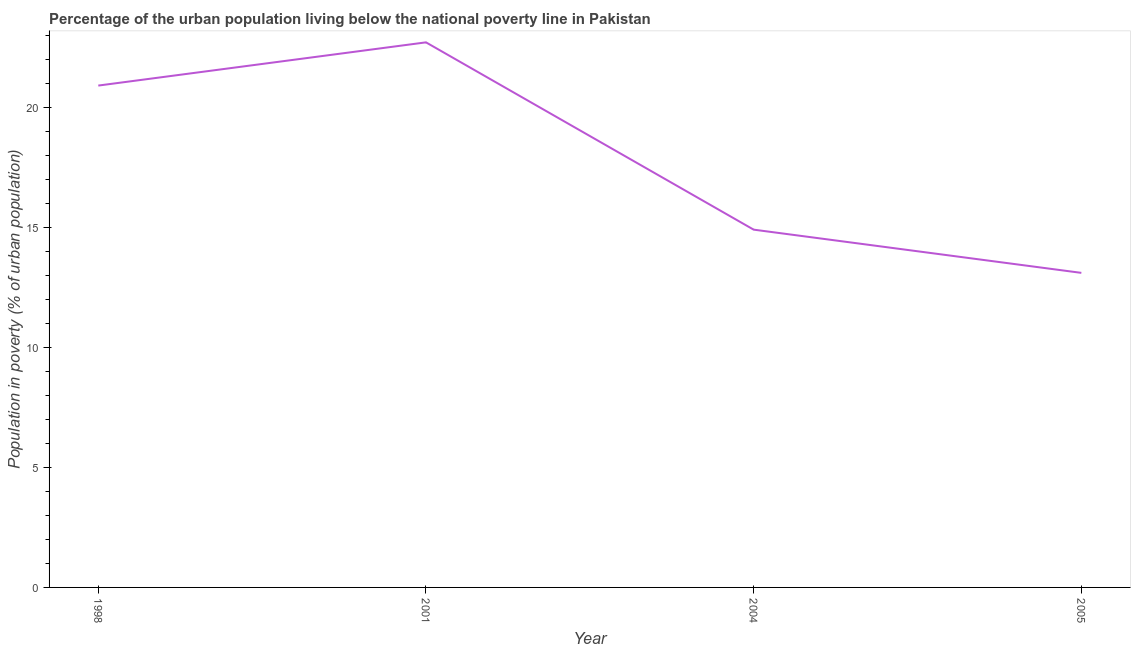Across all years, what is the maximum percentage of urban population living below poverty line?
Offer a very short reply. 22.7. Across all years, what is the minimum percentage of urban population living below poverty line?
Your response must be concise. 13.1. In which year was the percentage of urban population living below poverty line maximum?
Your answer should be compact. 2001. What is the sum of the percentage of urban population living below poverty line?
Give a very brief answer. 71.6. What is the difference between the percentage of urban population living below poverty line in 2004 and 2005?
Your answer should be very brief. 1.8. What is the average percentage of urban population living below poverty line per year?
Offer a very short reply. 17.9. What is the median percentage of urban population living below poverty line?
Keep it short and to the point. 17.9. What is the ratio of the percentage of urban population living below poverty line in 2004 to that in 2005?
Provide a short and direct response. 1.14. What is the difference between the highest and the second highest percentage of urban population living below poverty line?
Keep it short and to the point. 1.8. Is the sum of the percentage of urban population living below poverty line in 2001 and 2005 greater than the maximum percentage of urban population living below poverty line across all years?
Your answer should be very brief. Yes. In how many years, is the percentage of urban population living below poverty line greater than the average percentage of urban population living below poverty line taken over all years?
Keep it short and to the point. 2. How many years are there in the graph?
Your answer should be compact. 4. Are the values on the major ticks of Y-axis written in scientific E-notation?
Ensure brevity in your answer.  No. What is the title of the graph?
Offer a terse response. Percentage of the urban population living below the national poverty line in Pakistan. What is the label or title of the X-axis?
Your answer should be very brief. Year. What is the label or title of the Y-axis?
Ensure brevity in your answer.  Population in poverty (% of urban population). What is the Population in poverty (% of urban population) in 1998?
Your answer should be compact. 20.9. What is the Population in poverty (% of urban population) in 2001?
Provide a short and direct response. 22.7. What is the Population in poverty (% of urban population) in 2005?
Offer a very short reply. 13.1. What is the difference between the Population in poverty (% of urban population) in 1998 and 2001?
Keep it short and to the point. -1.8. What is the ratio of the Population in poverty (% of urban population) in 1998 to that in 2001?
Your answer should be compact. 0.92. What is the ratio of the Population in poverty (% of urban population) in 1998 to that in 2004?
Keep it short and to the point. 1.4. What is the ratio of the Population in poverty (% of urban population) in 1998 to that in 2005?
Provide a succinct answer. 1.59. What is the ratio of the Population in poverty (% of urban population) in 2001 to that in 2004?
Keep it short and to the point. 1.52. What is the ratio of the Population in poverty (% of urban population) in 2001 to that in 2005?
Offer a terse response. 1.73. What is the ratio of the Population in poverty (% of urban population) in 2004 to that in 2005?
Give a very brief answer. 1.14. 